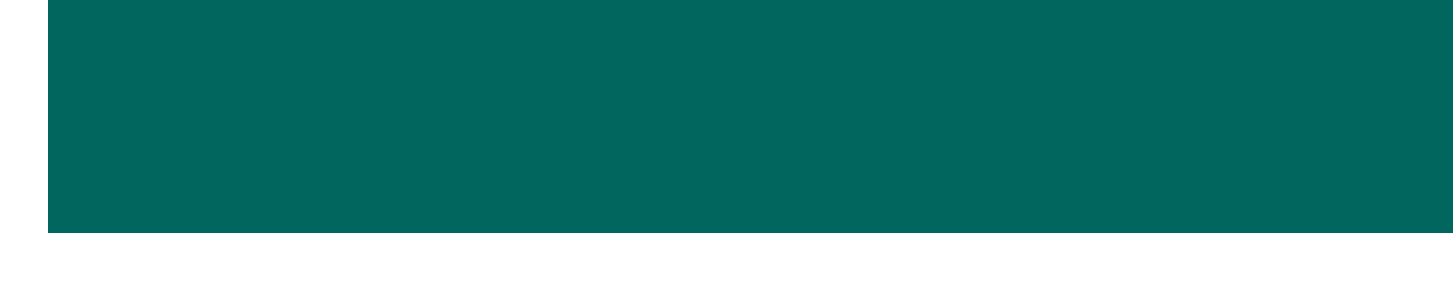What is the date of the Basant Kite Festival? The date for the Basant Kite Festival is mentioned in the upcoming events section as June 3, 2023.
Answer: June 3, 2023 Where is the Qawwali Night taking place? The venue for the Qawwali Night featuring Fareed Ayaz is specified in the document as Birmingham Town Hall.
Answer: Birmingham Town Hall What time does the Pakistan Independence Day Parade start? The starting time for the Pakistan Independence Day Parade is provided as 11:00 AM according to the event details.
Answer: 11:00 AM Who is the director of the movie "Khel Khel Mein"? The director is identified in the movie screenings section as Nabeel Qureshi.
Answer: Nabeel Qureshi Which community event occurs every Sunday? The document specifies that the "Pakistani Hour" on Sunrise Radio takes place every Sunday.
Answer: Pakistani Hour How much is the ticket for Qawwali Night? The ticket price for the Qawwali Night featuring Fareed Ayaz is mentioned as £25.
Answer: £25 What is the address of Lahore Karahi? The address for Lahore Karahi, as noted in the local businesses section, is 1-3 Tooting High Street, London SW17 0SN.
Answer: 1-3 Tooting High Street, London SW17 0SN What type of classes are offered at the Birmingham Central Mosque? The document describes that Urdu and Punjabi language classes are offered at the Birmingham Central Mosque.
Answer: Urdu and Punjabi When is the next movie screening after June 10, 2023? The next movie screening after June 10, 2023, is "Maula Jatt" on June 24, 2023.
Answer: June 24, 2023 What organization is seeking volunteers for the upcoming Eid festival? The organization mentioned in the community announcements as seeking volunteers is the British Pakistani Cultural Association.
Answer: British Pakistani Cultural Association 